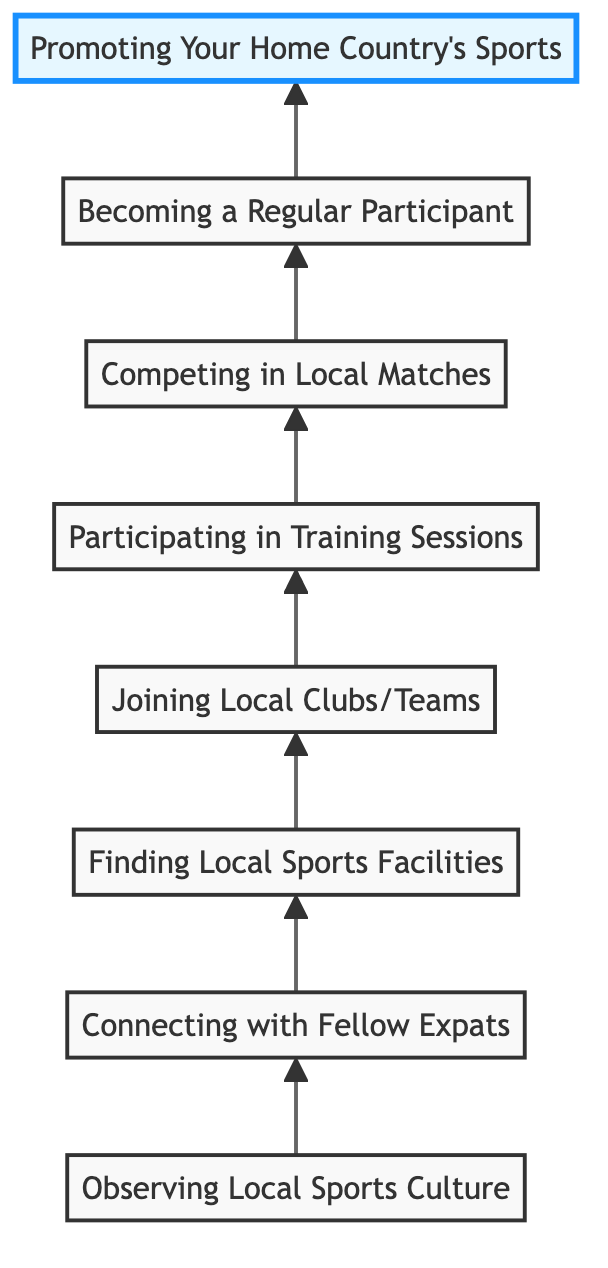What is the first stage in the transition process? The diagram indicates that the first stage is "Observing Local Sports Culture," which is positioned at the bottom of the flow chart.
Answer: Observing Local Sports Culture How many total stages are there in the diagram? By counting each stage listed from the bottom to the top in the diagram, there are a total of eight stages represented.
Answer: Eight What stage comes immediately after "Connecting with Fellow Expats"? In the flow chart, the stage that follows "Connecting with Fellow Expats" is "Finding Local Sports Facilities," which is directly linked above it.
Answer: Finding Local Sports Facilities What action is taken in the stage named "Competing in Local Matches"? The action described in this stage is "Participate in local friendly or competitive matches," indicating involvement in sports activities.
Answer: Participate in local friendly or competitive matches What is the relationship between "Participating in Training Sessions" and "Becoming a Regular Participant"? "Participating in Training Sessions" leads directly to "Becoming a Regular Participant," indicating that attending training is a prerequisite for becoming a regular in sports activities.
Answer: Leads to What is the last stage of the process outlined in the diagram? The final stage, positioned at the top of the flow chart, is "Promoting Your Home Country's Sports," which signifies the ultimate goal of the transition process.
Answer: Promoting Your Home Country's Sports In which stage is skill improvement primarily emphasized? The emphasis on skill improvement is highlighted in the "Participating in Training Sessions" stage, where regular training and practice are discussed.
Answer: Participating in Training Sessions What stage focuses on integration into the local sports community? Integration is focused on in the "Competing in Local Matches" stage, where participation in local events aims to enhance community involvement.
Answer: Competing in Local Matches Which stage supports the notion of cultural exchange? "Promoting Your Home Country's Sports" focuses on sharing knowledge and culture, thus supporting cultural exchange within the community.
Answer: Promoting Your Home Country's Sports 